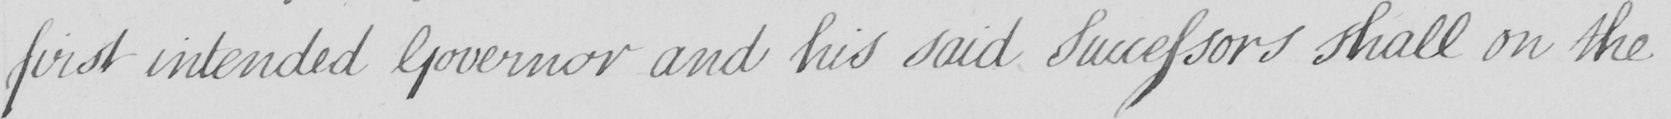Can you tell me what this handwritten text says? first intended Governor and his said Successors shall on the 